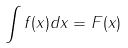Convert formula to latex. <formula><loc_0><loc_0><loc_500><loc_500>\int f ( x ) d x = F ( x )</formula> 